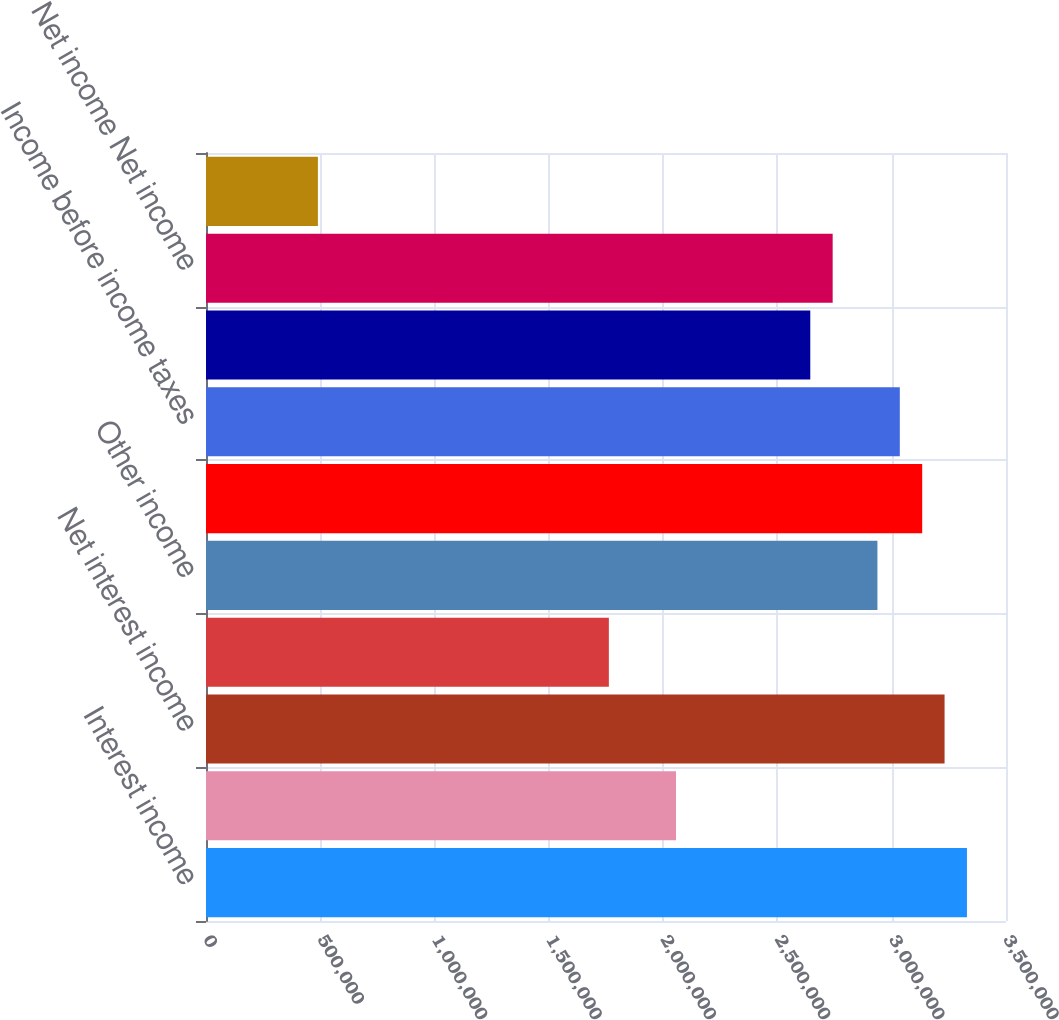Convert chart to OTSL. <chart><loc_0><loc_0><loc_500><loc_500><bar_chart><fcel>Interest income<fcel>Interest expense<fcel>Net interest income<fcel>Less provision for credit<fcel>Other income<fcel>Less other expense<fcel>Income before income taxes<fcel>Applicable income taxes<fcel>Net income Net income<fcel>Basic earnings<nl><fcel>3.32916e+06<fcel>2.05625e+06<fcel>3.23125e+06<fcel>1.7625e+06<fcel>2.9375e+06<fcel>3.13333e+06<fcel>3.03541e+06<fcel>2.64375e+06<fcel>2.74166e+06<fcel>489583<nl></chart> 